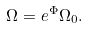Convert formula to latex. <formula><loc_0><loc_0><loc_500><loc_500>\Omega = e ^ { \Phi } \Omega _ { 0 } .</formula> 